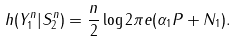Convert formula to latex. <formula><loc_0><loc_0><loc_500><loc_500>h ( Y ^ { n } _ { 1 } | S ^ { n } _ { 2 } ) = \frac { n } { 2 } \log 2 \pi e ( \alpha _ { 1 } P + N _ { 1 } ) .</formula> 